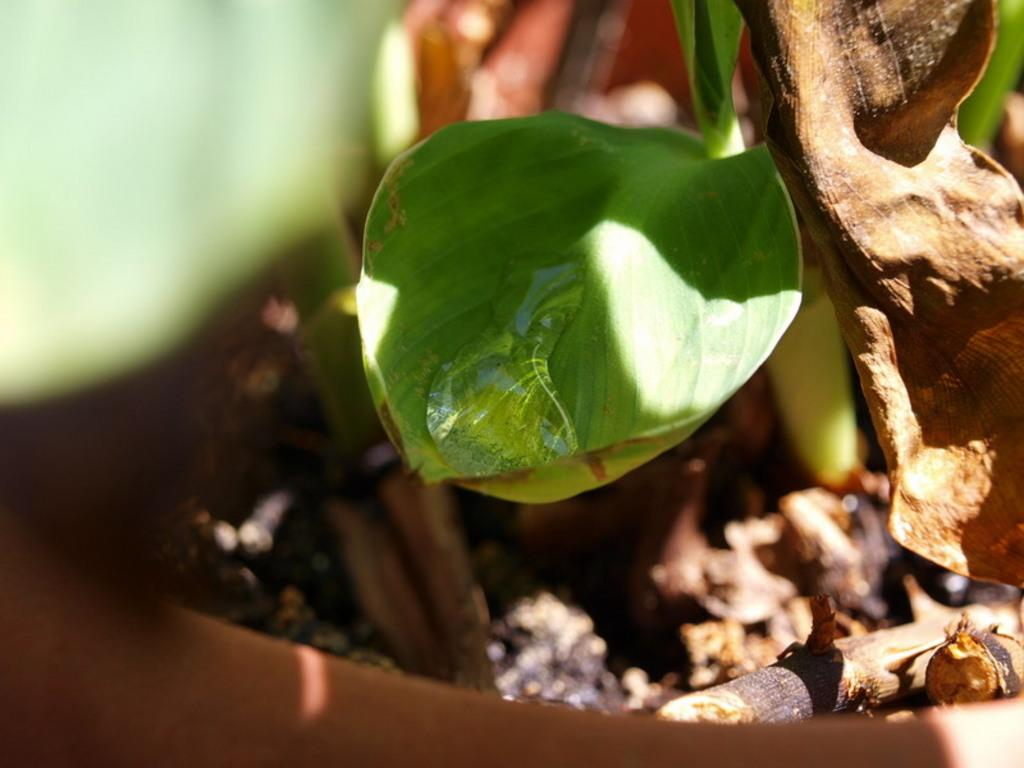What is the main subject of the image? The main subject of the image is a leaf of a tree. Can you describe the leaf in the image? Yes, there is a water droplet on the leaf. What is the weather like in the image? The climate is sunny. How is the background of the leaf depicted? The background of the leaf is blurred. How many women are involved in the lumber industry in the image? There are no women or references to the lumber industry in the image; it features a leaf with a water droplet and a blurred background. 